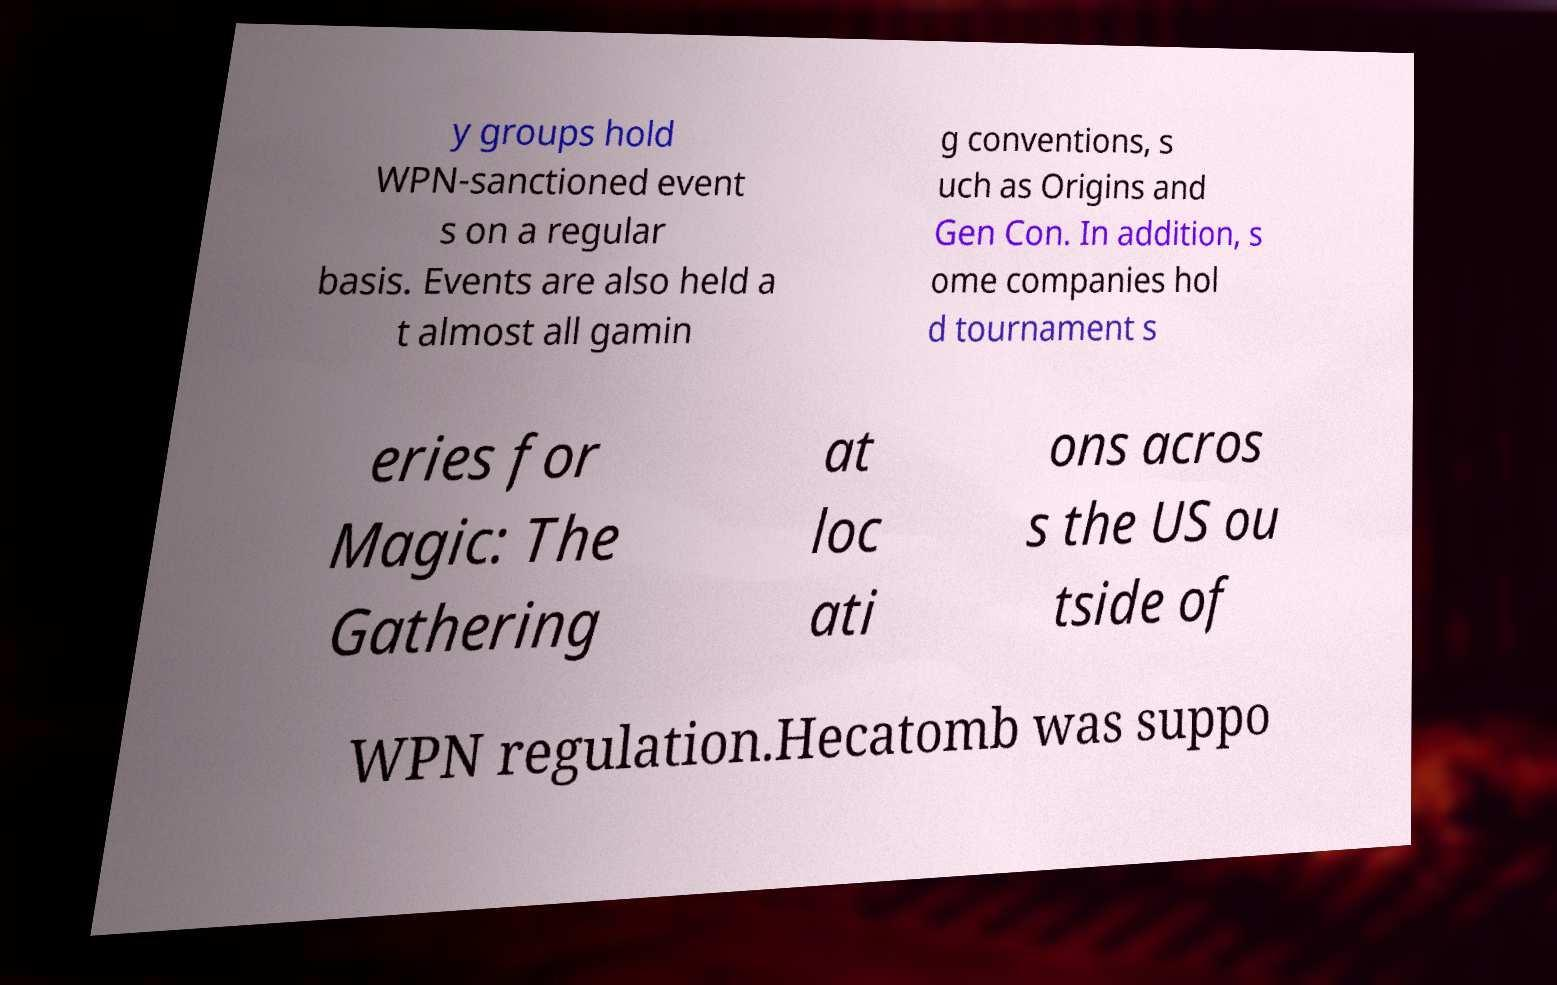Could you assist in decoding the text presented in this image and type it out clearly? y groups hold WPN-sanctioned event s on a regular basis. Events are also held a t almost all gamin g conventions, s uch as Origins and Gen Con. In addition, s ome companies hol d tournament s eries for Magic: The Gathering at loc ati ons acros s the US ou tside of WPN regulation.Hecatomb was suppo 